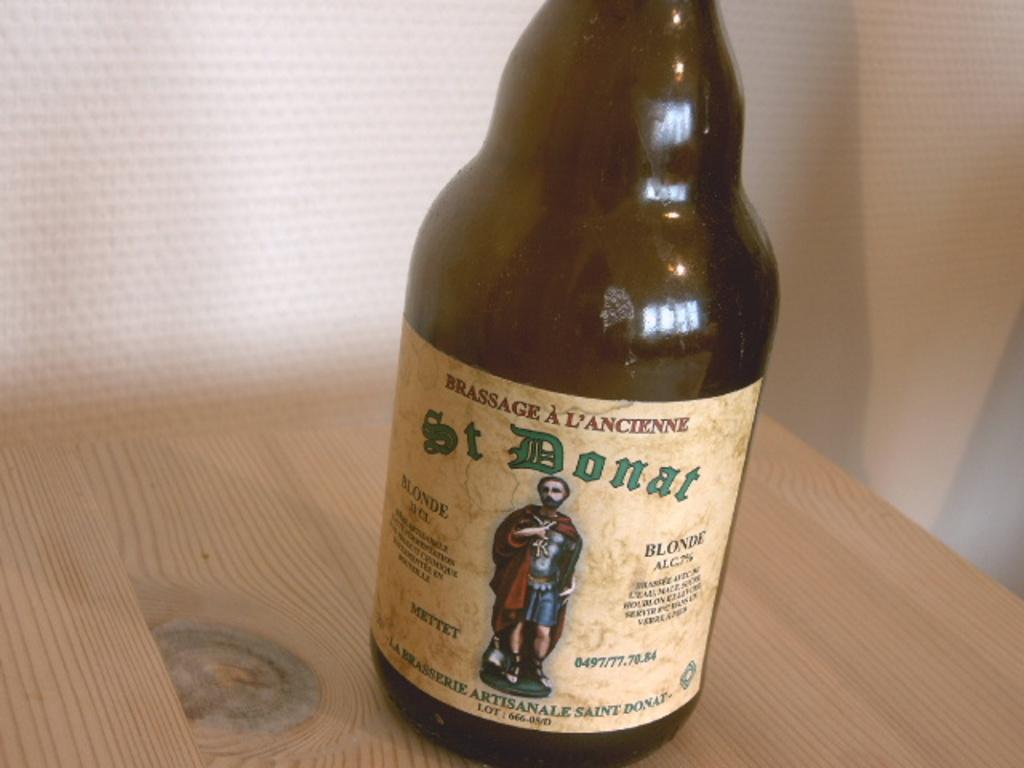What saint is on the bottle?
Provide a succinct answer. St. donat. What is the brand on the bottle?
Give a very brief answer. St donat. 